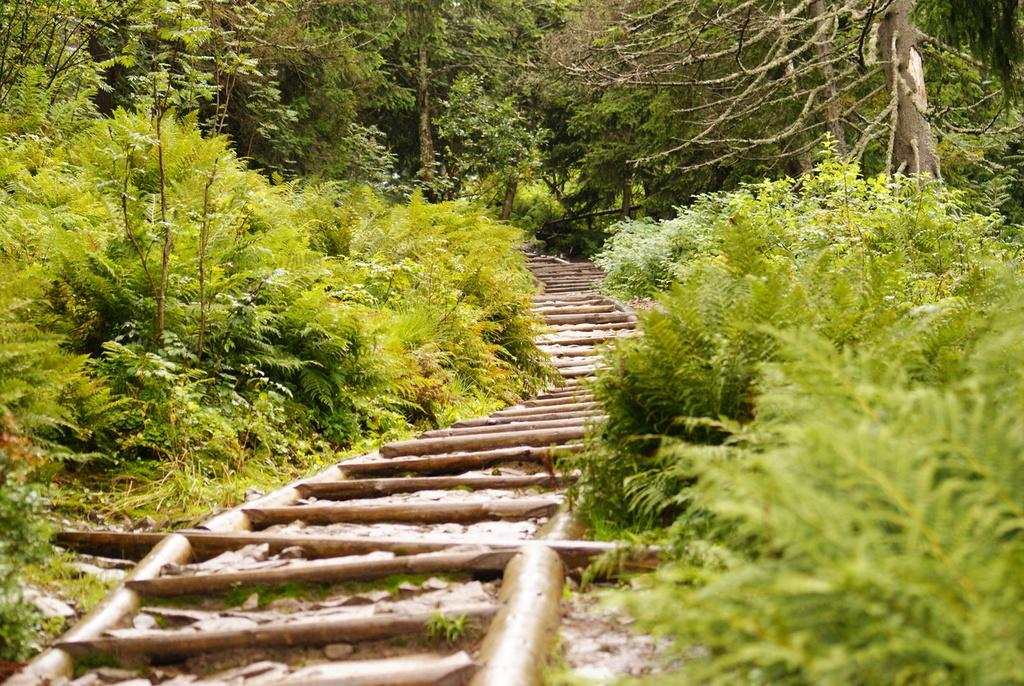What type of stairs are in the center of the image? There are wooden stairs in the center of the image. What can be seen on the right side of the image? There are trees on the right side of the image. What is located on the left side of the image? There are plants on the left side of the image. What type of ornament is hanging from the shoes in the image? There are no shoes or ornaments present in the image. What is the rake being used for in the image? There is no rake present in the image. 